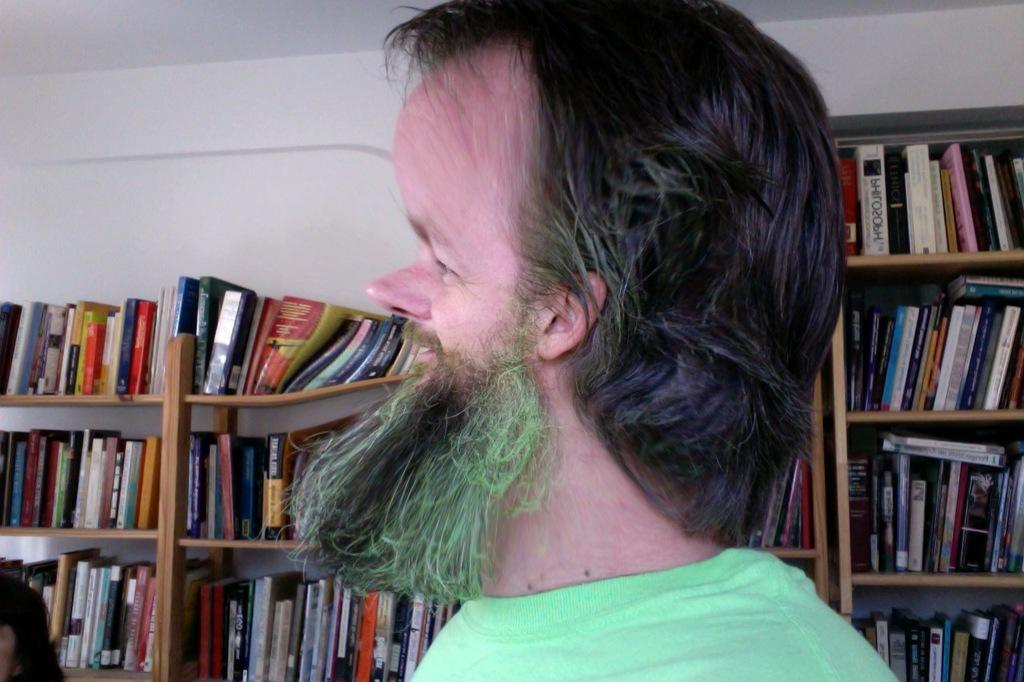Who is the main subject in the picture? There is a man in the middle of the picture. What can be seen in the background of the picture? There are books placed in the shelves in the background of the picture. What type of ground is visible in the picture? There is no ground visible in the picture; it appears to be an indoor setting with shelves and a man in the middle. 